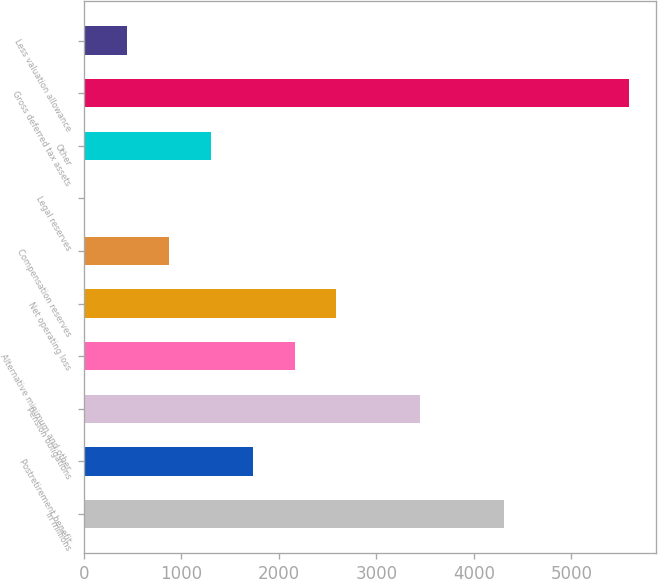<chart> <loc_0><loc_0><loc_500><loc_500><bar_chart><fcel>In millions<fcel>Postretirement benefit<fcel>Pension obligations<fcel>Alternative minimum and other<fcel>Net operating loss<fcel>Compensation reserves<fcel>Legal reserves<fcel>Other<fcel>Gross deferred tax assets<fcel>Less valuation allowance<nl><fcel>4307<fcel>1732.4<fcel>3448.8<fcel>2161.5<fcel>2590.6<fcel>874.2<fcel>16<fcel>1303.3<fcel>5594.3<fcel>445.1<nl></chart> 